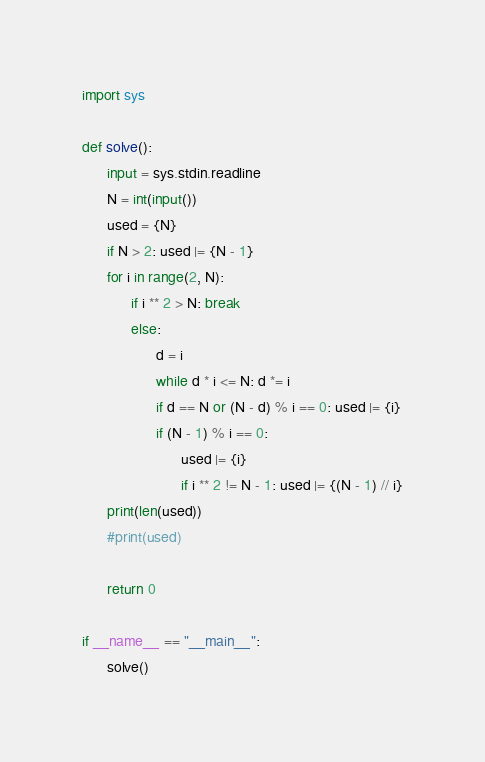Convert code to text. <code><loc_0><loc_0><loc_500><loc_500><_Python_>import sys

def solve():
      input = sys.stdin.readline
      N = int(input())
      used = {N}
      if N > 2: used |= {N - 1}
      for i in range(2, N):
            if i ** 2 > N: break
            else:
                  d = i
                  while d * i <= N: d *= i
                  if d == N or (N - d) % i == 0: used |= {i}
                  if (N - 1) % i == 0:
                        used |= {i}
                        if i ** 2 != N - 1: used |= {(N - 1) // i}
      print(len(used))
      #print(used)

      return 0

if __name__ == "__main__":
      solve()</code> 